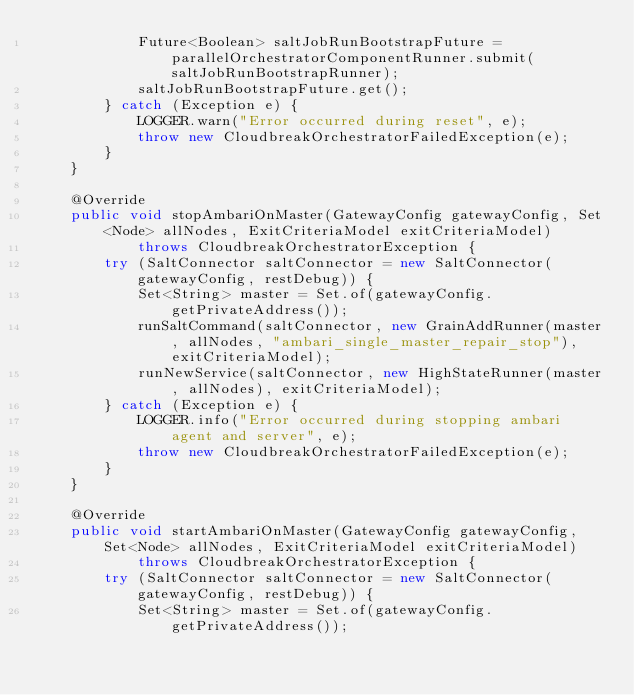<code> <loc_0><loc_0><loc_500><loc_500><_Java_>            Future<Boolean> saltJobRunBootstrapFuture = parallelOrchestratorComponentRunner.submit(saltJobRunBootstrapRunner);
            saltJobRunBootstrapFuture.get();
        } catch (Exception e) {
            LOGGER.warn("Error occurred during reset", e);
            throw new CloudbreakOrchestratorFailedException(e);
        }
    }

    @Override
    public void stopAmbariOnMaster(GatewayConfig gatewayConfig, Set<Node> allNodes, ExitCriteriaModel exitCriteriaModel)
            throws CloudbreakOrchestratorException {
        try (SaltConnector saltConnector = new SaltConnector(gatewayConfig, restDebug)) {
            Set<String> master = Set.of(gatewayConfig.getPrivateAddress());
            runSaltCommand(saltConnector, new GrainAddRunner(master, allNodes, "ambari_single_master_repair_stop"), exitCriteriaModel);
            runNewService(saltConnector, new HighStateRunner(master, allNodes), exitCriteriaModel);
        } catch (Exception e) {
            LOGGER.info("Error occurred during stopping ambari agent and server", e);
            throw new CloudbreakOrchestratorFailedException(e);
        }
    }

    @Override
    public void startAmbariOnMaster(GatewayConfig gatewayConfig, Set<Node> allNodes, ExitCriteriaModel exitCriteriaModel)
            throws CloudbreakOrchestratorException {
        try (SaltConnector saltConnector = new SaltConnector(gatewayConfig, restDebug)) {
            Set<String> master = Set.of(gatewayConfig.getPrivateAddress());</code> 